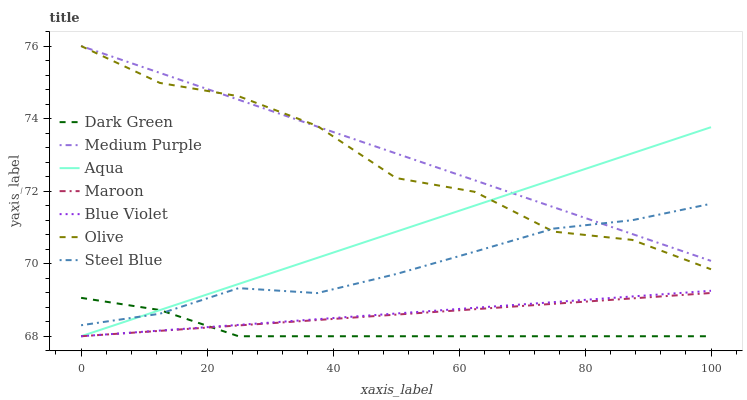Does Dark Green have the minimum area under the curve?
Answer yes or no. Yes. Does Medium Purple have the maximum area under the curve?
Answer yes or no. Yes. Does Steel Blue have the minimum area under the curve?
Answer yes or no. No. Does Steel Blue have the maximum area under the curve?
Answer yes or no. No. Is Maroon the smoothest?
Answer yes or no. Yes. Is Olive the roughest?
Answer yes or no. Yes. Is Steel Blue the smoothest?
Answer yes or no. No. Is Steel Blue the roughest?
Answer yes or no. No. Does Aqua have the lowest value?
Answer yes or no. Yes. Does Steel Blue have the lowest value?
Answer yes or no. No. Does Olive have the highest value?
Answer yes or no. Yes. Does Steel Blue have the highest value?
Answer yes or no. No. Is Maroon less than Medium Purple?
Answer yes or no. Yes. Is Medium Purple greater than Maroon?
Answer yes or no. Yes. Does Dark Green intersect Blue Violet?
Answer yes or no. Yes. Is Dark Green less than Blue Violet?
Answer yes or no. No. Is Dark Green greater than Blue Violet?
Answer yes or no. No. Does Maroon intersect Medium Purple?
Answer yes or no. No. 